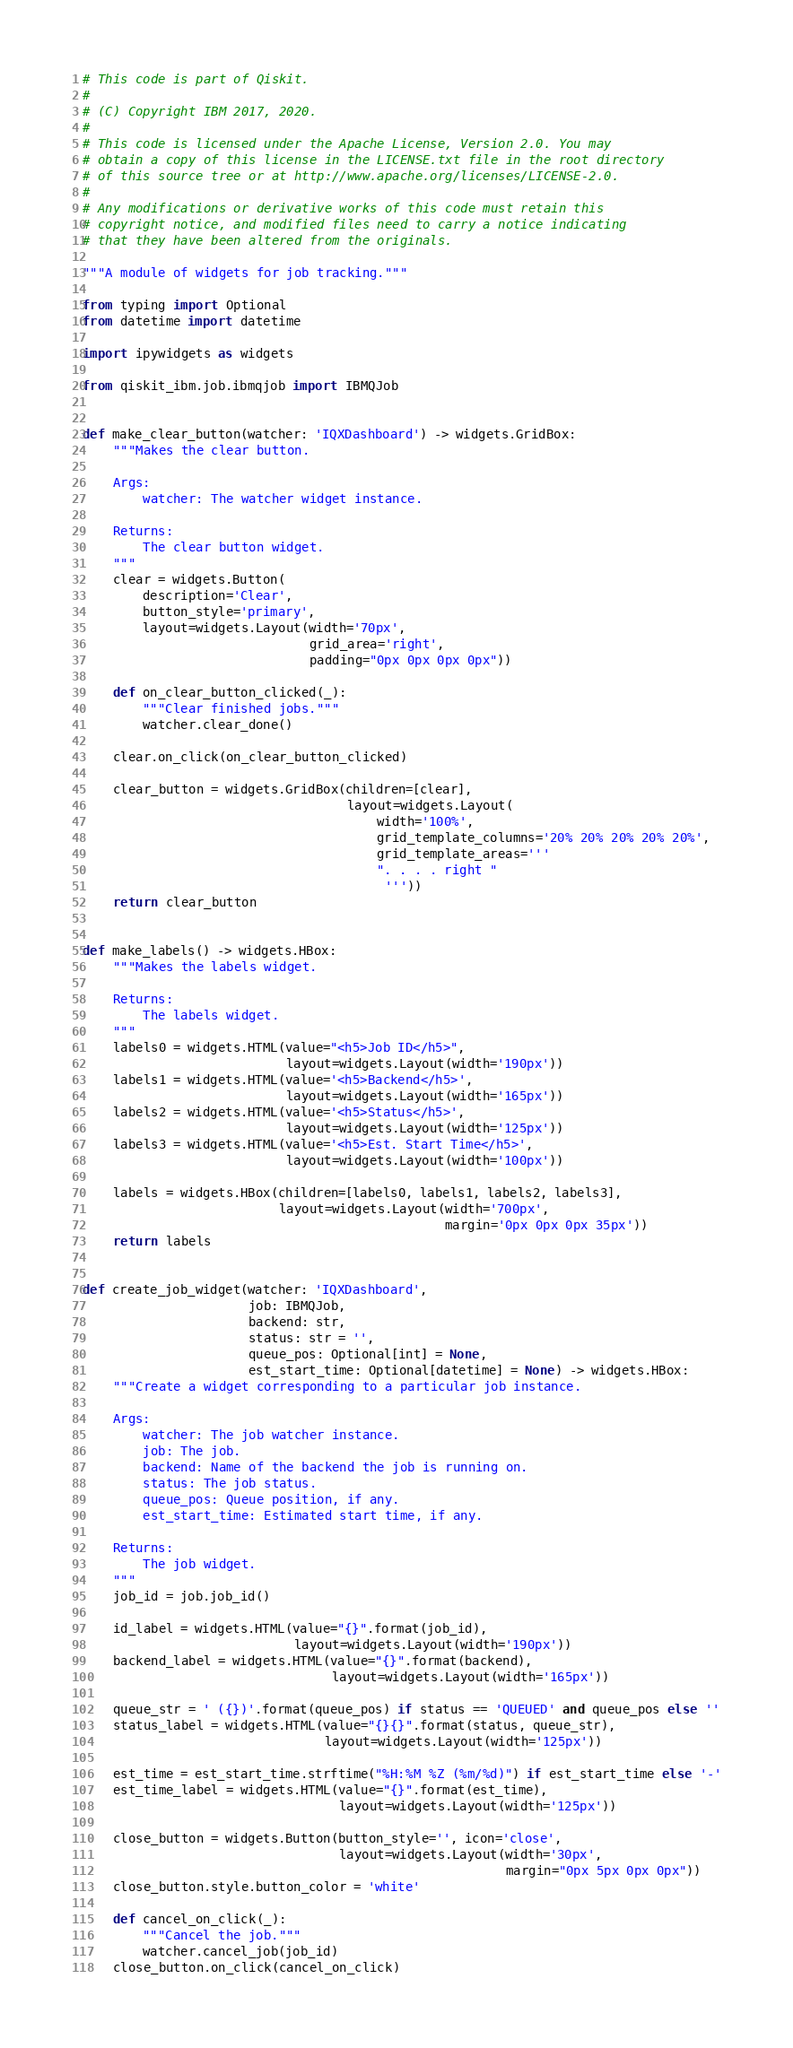Convert code to text. <code><loc_0><loc_0><loc_500><loc_500><_Python_># This code is part of Qiskit.
#
# (C) Copyright IBM 2017, 2020.
#
# This code is licensed under the Apache License, Version 2.0. You may
# obtain a copy of this license in the LICENSE.txt file in the root directory
# of this source tree or at http://www.apache.org/licenses/LICENSE-2.0.
#
# Any modifications or derivative works of this code must retain this
# copyright notice, and modified files need to carry a notice indicating
# that they have been altered from the originals.

"""A module of widgets for job tracking."""

from typing import Optional
from datetime import datetime

import ipywidgets as widgets

from qiskit_ibm.job.ibmqjob import IBMQJob


def make_clear_button(watcher: 'IQXDashboard') -> widgets.GridBox:
    """Makes the clear button.

    Args:
        watcher: The watcher widget instance.

    Returns:
        The clear button widget.
    """
    clear = widgets.Button(
        description='Clear',
        button_style='primary',
        layout=widgets.Layout(width='70px',
                              grid_area='right',
                              padding="0px 0px 0px 0px"))

    def on_clear_button_clicked(_):
        """Clear finished jobs."""
        watcher.clear_done()

    clear.on_click(on_clear_button_clicked)

    clear_button = widgets.GridBox(children=[clear],
                                   layout=widgets.Layout(
                                       width='100%',
                                       grid_template_columns='20% 20% 20% 20% 20%',
                                       grid_template_areas='''
                                       ". . . . right "
                                        '''))
    return clear_button


def make_labels() -> widgets.HBox:
    """Makes the labels widget.

    Returns:
        The labels widget.
    """
    labels0 = widgets.HTML(value="<h5>Job ID</h5>",
                           layout=widgets.Layout(width='190px'))
    labels1 = widgets.HTML(value='<h5>Backend</h5>',
                           layout=widgets.Layout(width='165px'))
    labels2 = widgets.HTML(value='<h5>Status</h5>',
                           layout=widgets.Layout(width='125px'))
    labels3 = widgets.HTML(value='<h5>Est. Start Time</h5>',
                           layout=widgets.Layout(width='100px'))

    labels = widgets.HBox(children=[labels0, labels1, labels2, labels3],
                          layout=widgets.Layout(width='700px',
                                                margin='0px 0px 0px 35px'))
    return labels


def create_job_widget(watcher: 'IQXDashboard',
                      job: IBMQJob,
                      backend: str,
                      status: str = '',
                      queue_pos: Optional[int] = None,
                      est_start_time: Optional[datetime] = None) -> widgets.HBox:
    """Create a widget corresponding to a particular job instance.

    Args:
        watcher: The job watcher instance.
        job: The job.
        backend: Name of the backend the job is running on.
        status: The job status.
        queue_pos: Queue position, if any.
        est_start_time: Estimated start time, if any.

    Returns:
        The job widget.
    """
    job_id = job.job_id()

    id_label = widgets.HTML(value="{}".format(job_id),
                            layout=widgets.Layout(width='190px'))
    backend_label = widgets.HTML(value="{}".format(backend),
                                 layout=widgets.Layout(width='165px'))

    queue_str = ' ({})'.format(queue_pos) if status == 'QUEUED' and queue_pos else ''
    status_label = widgets.HTML(value="{}{}".format(status, queue_str),
                                layout=widgets.Layout(width='125px'))

    est_time = est_start_time.strftime("%H:%M %Z (%m/%d)") if est_start_time else '-'
    est_time_label = widgets.HTML(value="{}".format(est_time),
                                  layout=widgets.Layout(width='125px'))

    close_button = widgets.Button(button_style='', icon='close',
                                  layout=widgets.Layout(width='30px',
                                                        margin="0px 5px 0px 0px"))
    close_button.style.button_color = 'white'

    def cancel_on_click(_):
        """Cancel the job."""
        watcher.cancel_job(job_id)
    close_button.on_click(cancel_on_click)
</code> 